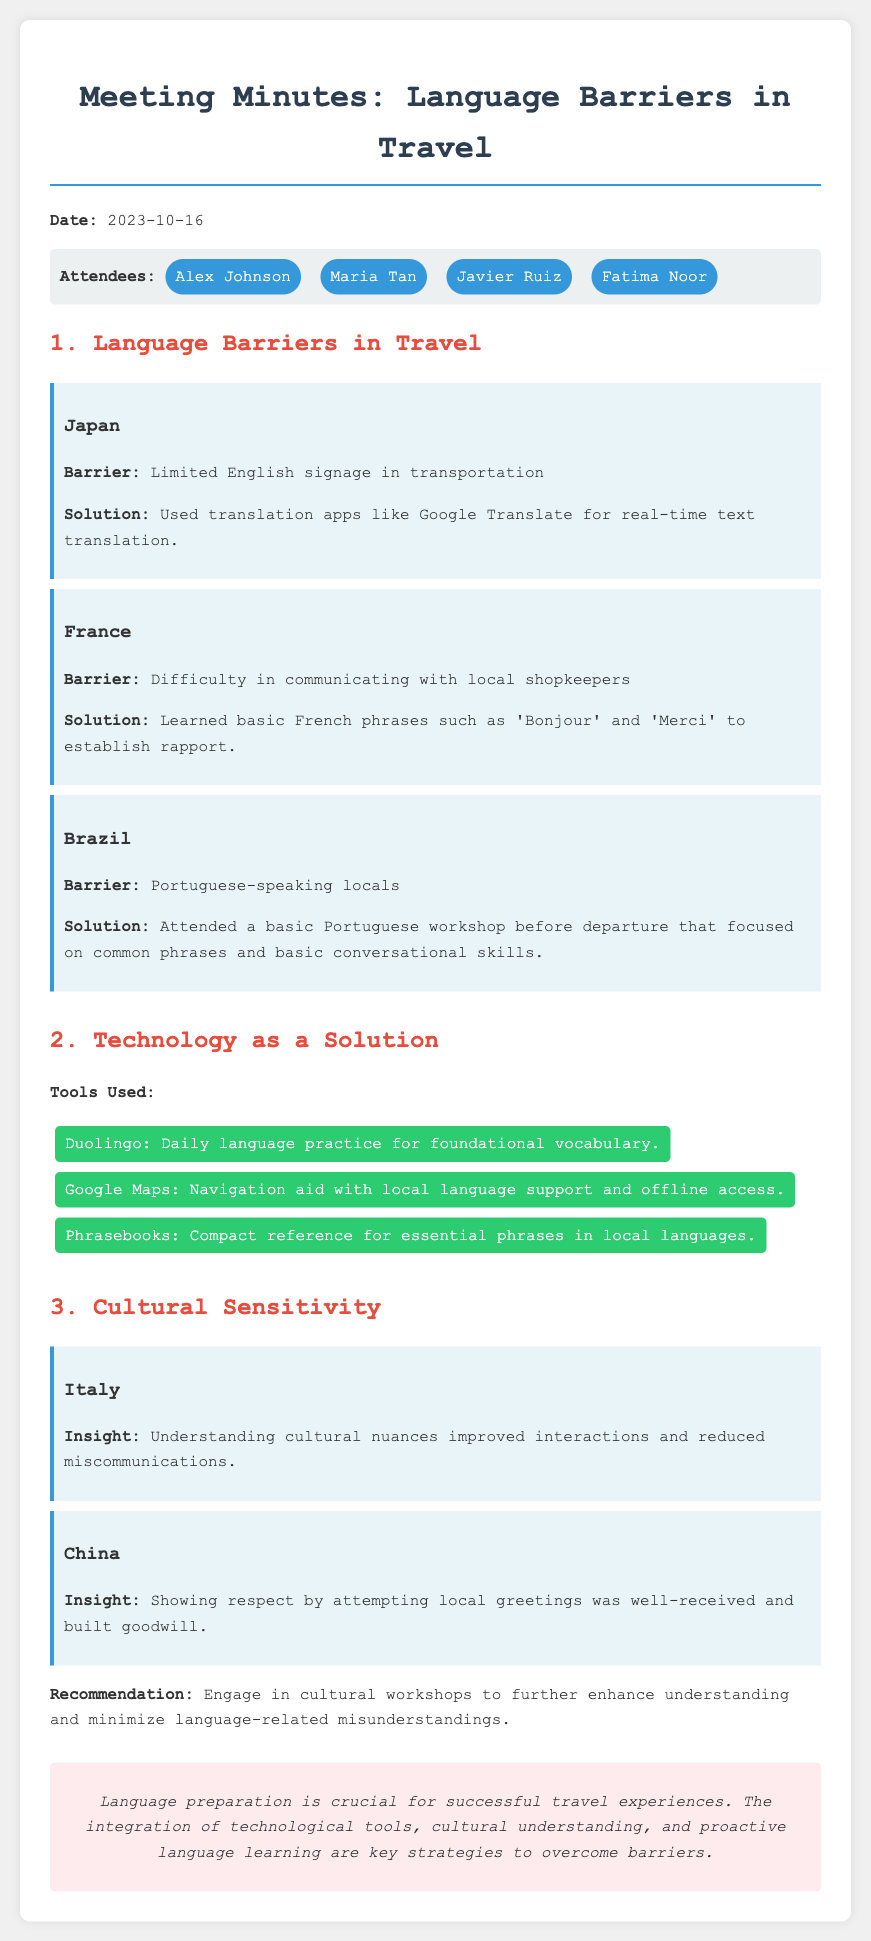What is the date of the meeting? The date of the meeting is specified at the beginning of the document.
Answer: 2023-10-16 Who is the attendee from Brazil? The document lists the attendees in a section, and we need to identify who is from Brazil.
Answer: Javier Ruiz What language tool was used for daily practice? This is found in the section discussing technology as a solution, which lists different tools.
Answer: Duolingo What barrier was encountered in France? The barrier encountered is detailed in the section about language barriers in travel, specifically for France.
Answer: Difficulty in communicating with local shopkeepers Which country’s experience emphasized cultural nuances? The document mentions various countries in the cultural sensitivity section; we need to identify which one specifically mentioned cultural nuances.
Answer: Italy How was the language barrier addressed in Japan? The solution to the barrier in Japan is discussed in the Japan section of language barriers, indicating a specific approach taken.
Answer: Used translation apps like Google Translate What recommendation is given for improving cultural understanding? There is a specific recommendation provided in the cultural sensitivity section about engaging in workshops.
Answer: Engage in cultural workshops Which attendees were present during the meeting? The attendees are listed at the beginning of the document; we need to identify all names mentioned.
Answer: Alex Johnson, Maria Tan, Javier Ruiz, Fatima Noor 